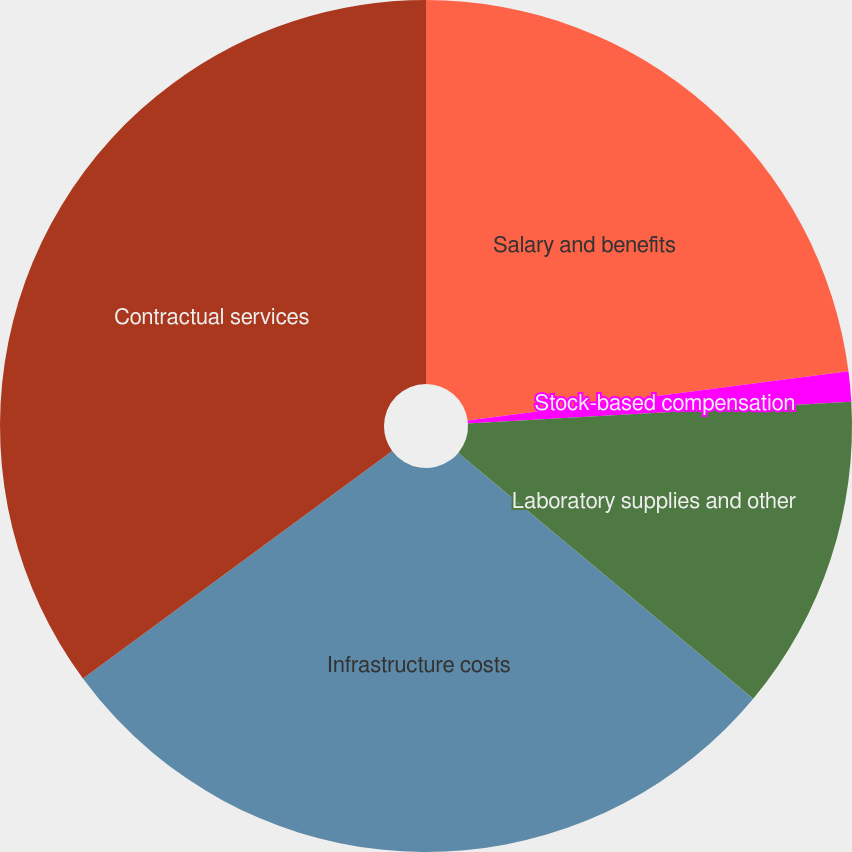Convert chart to OTSL. <chart><loc_0><loc_0><loc_500><loc_500><pie_chart><fcel>Salary and benefits<fcel>Stock-based compensation<fcel>Laboratory supplies and other<fcel>Infrastructure costs<fcel>Contractual services<nl><fcel>22.95%<fcel>1.14%<fcel>11.97%<fcel>28.84%<fcel>35.1%<nl></chart> 